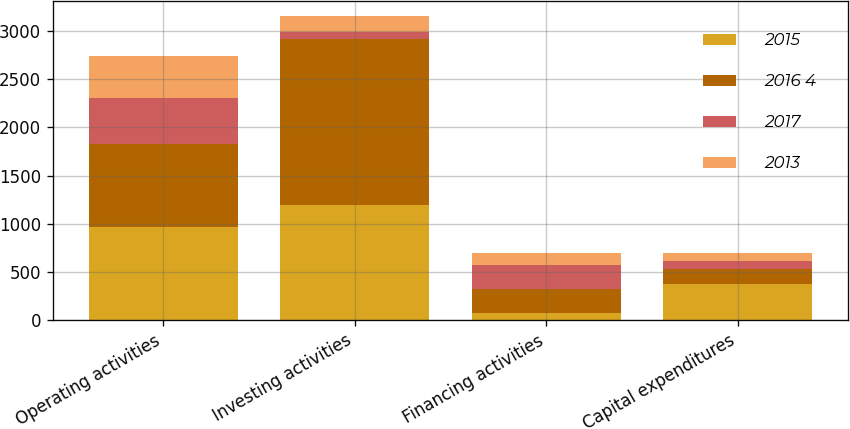Convert chart to OTSL. <chart><loc_0><loc_0><loc_500><loc_500><stacked_bar_chart><ecel><fcel>Operating activities<fcel>Investing activities<fcel>Financing activities<fcel>Capital expenditures<nl><fcel>2015<fcel>970<fcel>1190<fcel>72<fcel>369<nl><fcel>2016 4<fcel>860<fcel>1731<fcel>249<fcel>164<nl><fcel>2017<fcel>476<fcel>67<fcel>249<fcel>78<nl><fcel>2013<fcel>433<fcel>173<fcel>130<fcel>83<nl></chart> 